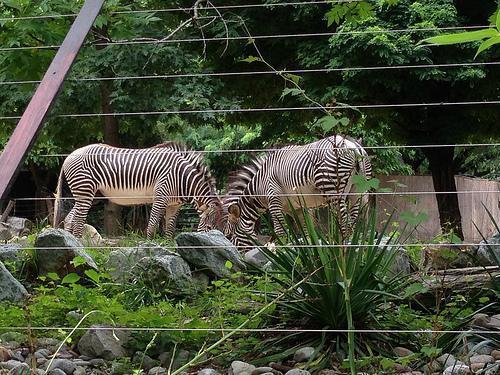How many zebras are there?
Give a very brief answer. 2. 